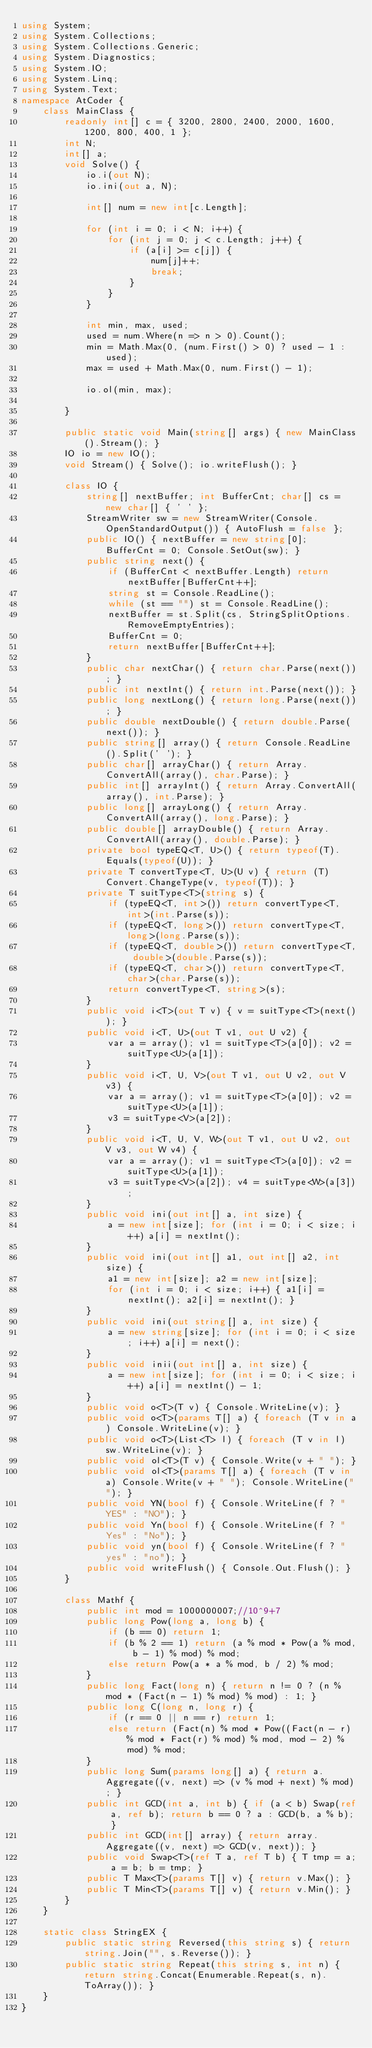Convert code to text. <code><loc_0><loc_0><loc_500><loc_500><_C#_>using System;
using System.Collections;
using System.Collections.Generic;
using System.Diagnostics;
using System.IO;
using System.Linq;
using System.Text;
namespace AtCoder {
    class MainClass {
        readonly int[] c = { 3200, 2800, 2400, 2000, 1600, 1200, 800, 400, 1 };
        int N;
        int[] a;
        void Solve() {
            io.i(out N);
            io.ini(out a, N);

            int[] num = new int[c.Length];

            for (int i = 0; i < N; i++) {
                for (int j = 0; j < c.Length; j++) {
                    if (a[i] >= c[j]) {
                        num[j]++;
                        break;
                    }
                }
            }

            int min, max, used;
            used = num.Where(n => n > 0).Count();
            min = Math.Max(0, (num.First() > 0) ? used - 1 : used);
            max = used + Math.Max(0, num.First() - 1);

            io.ol(min, max);

        }

        public static void Main(string[] args) { new MainClass().Stream(); }
        IO io = new IO();
        void Stream() { Solve(); io.writeFlush(); }

        class IO {
            string[] nextBuffer; int BufferCnt; char[] cs = new char[] { ' ' };
            StreamWriter sw = new StreamWriter(Console.OpenStandardOutput()) { AutoFlush = false };
            public IO() { nextBuffer = new string[0]; BufferCnt = 0; Console.SetOut(sw); }
            public string next() {
                if (BufferCnt < nextBuffer.Length) return nextBuffer[BufferCnt++];
                string st = Console.ReadLine();
                while (st == "") st = Console.ReadLine();
                nextBuffer = st.Split(cs, StringSplitOptions.RemoveEmptyEntries);
                BufferCnt = 0;
                return nextBuffer[BufferCnt++];
            }
            public char nextChar() { return char.Parse(next()); }
            public int nextInt() { return int.Parse(next()); }
            public long nextLong() { return long.Parse(next()); }
            public double nextDouble() { return double.Parse(next()); }
            public string[] array() { return Console.ReadLine().Split(' '); }
            public char[] arrayChar() { return Array.ConvertAll(array(), char.Parse); }
            public int[] arrayInt() { return Array.ConvertAll(array(), int.Parse); }
            public long[] arrayLong() { return Array.ConvertAll(array(), long.Parse); }
            public double[] arrayDouble() { return Array.ConvertAll(array(), double.Parse); }
            private bool typeEQ<T, U>() { return typeof(T).Equals(typeof(U)); }
            private T convertType<T, U>(U v) { return (T)Convert.ChangeType(v, typeof(T)); }
            private T suitType<T>(string s) {
                if (typeEQ<T, int>()) return convertType<T, int>(int.Parse(s));
                if (typeEQ<T, long>()) return convertType<T, long>(long.Parse(s));
                if (typeEQ<T, double>()) return convertType<T, double>(double.Parse(s));
                if (typeEQ<T, char>()) return convertType<T, char>(char.Parse(s));
                return convertType<T, string>(s);
            }
            public void i<T>(out T v) { v = suitType<T>(next()); }
            public void i<T, U>(out T v1, out U v2) {
                var a = array(); v1 = suitType<T>(a[0]); v2 = suitType<U>(a[1]);
            }
            public void i<T, U, V>(out T v1, out U v2, out V v3) {
                var a = array(); v1 = suitType<T>(a[0]); v2 = suitType<U>(a[1]);
                v3 = suitType<V>(a[2]);
            }
            public void i<T, U, V, W>(out T v1, out U v2, out V v3, out W v4) {
                var a = array(); v1 = suitType<T>(a[0]); v2 = suitType<U>(a[1]);
                v3 = suitType<V>(a[2]); v4 = suitType<W>(a[3]);
            }
            public void ini(out int[] a, int size) {
                a = new int[size]; for (int i = 0; i < size; i++) a[i] = nextInt();
            }
            public void ini(out int[] a1, out int[] a2, int size) {
                a1 = new int[size]; a2 = new int[size];
                for (int i = 0; i < size; i++) { a1[i] = nextInt(); a2[i] = nextInt(); }
            }
            public void ini(out string[] a, int size) {
                a = new string[size]; for (int i = 0; i < size; i++) a[i] = next();
            }
            public void inii(out int[] a, int size) {
                a = new int[size]; for (int i = 0; i < size; i++) a[i] = nextInt() - 1;
            }
            public void o<T>(T v) { Console.WriteLine(v); }
            public void o<T>(params T[] a) { foreach (T v in a) Console.WriteLine(v); }
            public void o<T>(List<T> l) { foreach (T v in l) sw.WriteLine(v); }
            public void ol<T>(T v) { Console.Write(v + " "); }
            public void ol<T>(params T[] a) { foreach (T v in a) Console.Write(v + " "); Console.WriteLine(""); }
            public void YN(bool f) { Console.WriteLine(f ? "YES" : "NO"); }
            public void Yn(bool f) { Console.WriteLine(f ? "Yes" : "No"); }
            public void yn(bool f) { Console.WriteLine(f ? "yes" : "no"); }
            public void writeFlush() { Console.Out.Flush(); }
        }

        class Mathf {
            public int mod = 1000000007;//10^9+7
            public long Pow(long a, long b) {
                if (b == 0) return 1;
                if (b % 2 == 1) return (a % mod * Pow(a % mod, b - 1) % mod) % mod;
                else return Pow(a * a % mod, b / 2) % mod;
            }
            public long Fact(long n) { return n != 0 ? (n % mod * (Fact(n - 1) % mod) % mod) : 1; }
            public long C(long n, long r) {
                if (r == 0 || n == r) return 1;
                else return (Fact(n) % mod * Pow((Fact(n - r) % mod * Fact(r) % mod) % mod, mod - 2) % mod) % mod;
            }
            public long Sum(params long[] a) { return a.Aggregate((v, next) => (v % mod + next) % mod); }
            public int GCD(int a, int b) { if (a < b) Swap(ref a, ref b); return b == 0 ? a : GCD(b, a % b); }
            public int GCD(int[] array) { return array.Aggregate((v, next) => GCD(v, next)); }
            public void Swap<T>(ref T a, ref T b) { T tmp = a; a = b; b = tmp; }
            public T Max<T>(params T[] v) { return v.Max(); }
            public T Min<T>(params T[] v) { return v.Min(); }
        }
    }

    static class StringEX {
        public static string Reversed(this string s) { return string.Join("", s.Reverse()); }
        public static string Repeat(this string s, int n) { return string.Concat(Enumerable.Repeat(s, n).ToArray()); }
    }
}</code> 